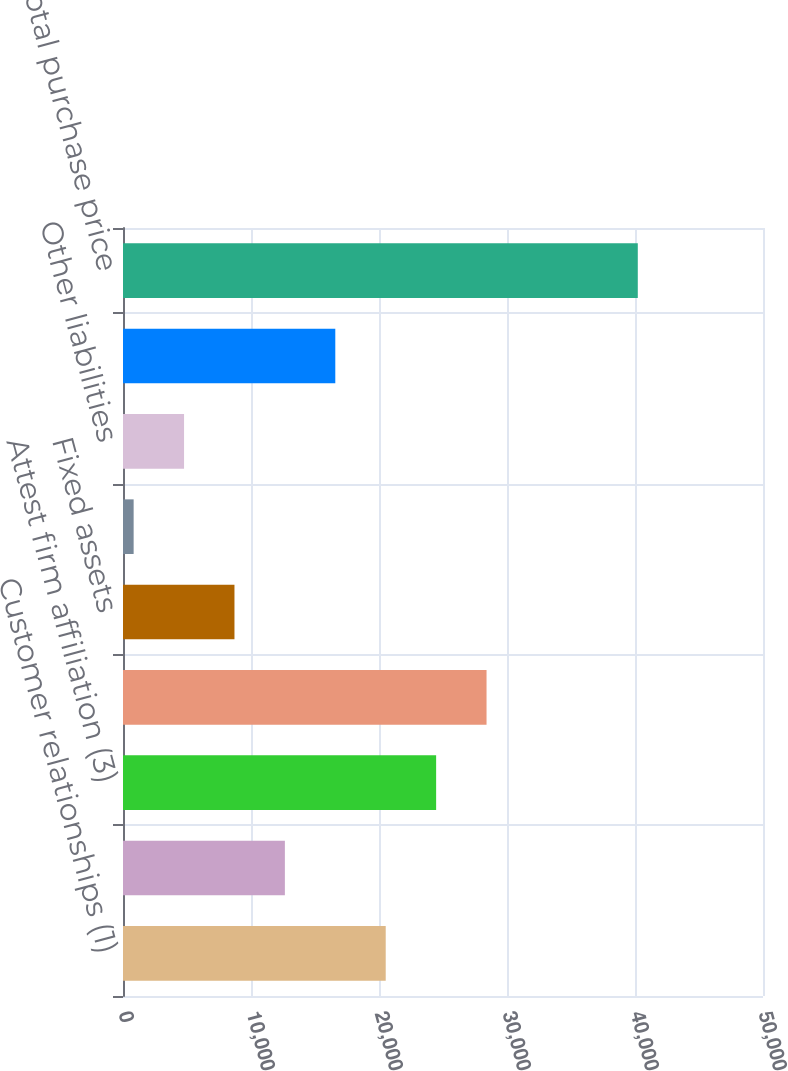Convert chart to OTSL. <chart><loc_0><loc_0><loc_500><loc_500><bar_chart><fcel>Customer relationships (1)<fcel>Non-compete agreements (2)<fcel>Attest firm affiliation (3)<fcel>Goodwill<fcel>Fixed assets<fcel>Other assets<fcel>Other liabilities<fcel>Unfavorable leasehold (2)<fcel>Total purchase price<nl><fcel>20524.5<fcel>12647.1<fcel>24463.2<fcel>28401.9<fcel>8708.4<fcel>831<fcel>4769.7<fcel>16585.8<fcel>40218<nl></chart> 